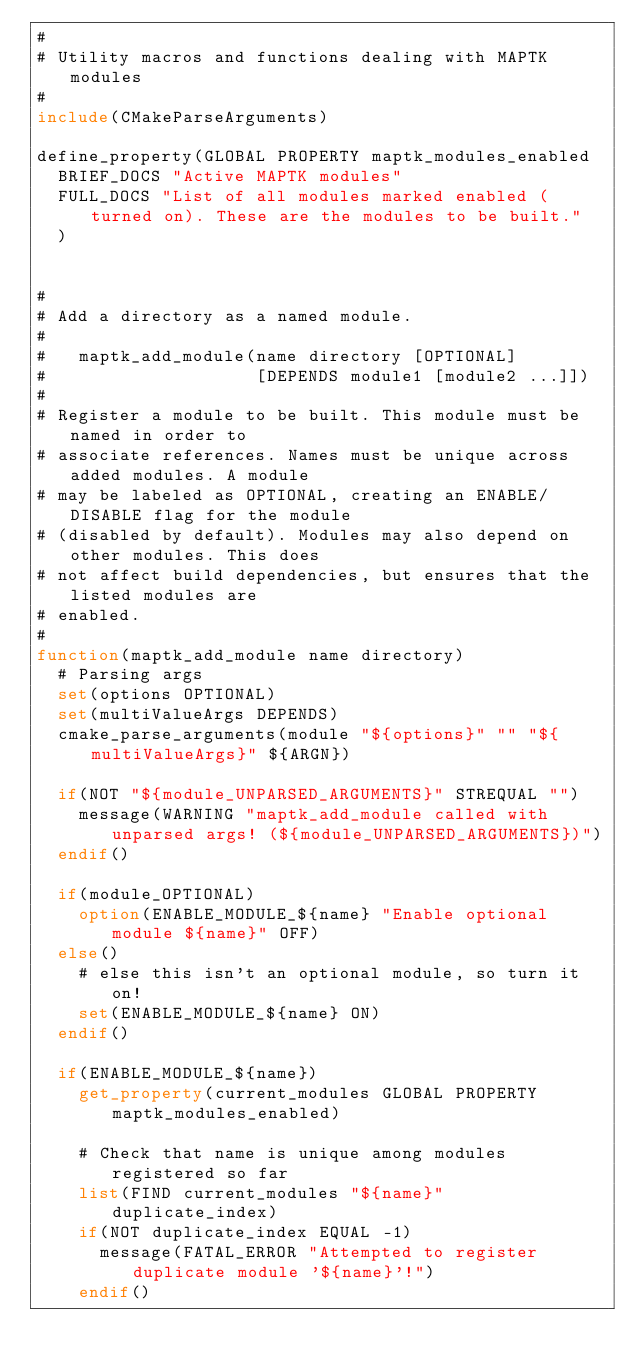Convert code to text. <code><loc_0><loc_0><loc_500><loc_500><_CMake_>#
# Utility macros and functions dealing with MAPTK modules
#
include(CMakeParseArguments)

define_property(GLOBAL PROPERTY maptk_modules_enabled
  BRIEF_DOCS "Active MAPTK modules"
  FULL_DOCS "List of all modules marked enabled (turned on). These are the modules to be built."
  )


#
# Add a directory as a named module.
#
#   maptk_add_module(name directory [OPTIONAL]
#                    [DEPENDS module1 [module2 ...]])
#
# Register a module to be built. This module must be named in order to
# associate references. Names must be unique across added modules. A module
# may be labeled as OPTIONAL, creating an ENABLE/DISABLE flag for the module
# (disabled by default). Modules may also depend on other modules. This does
# not affect build dependencies, but ensures that the listed modules are
# enabled.
#
function(maptk_add_module name directory)
  # Parsing args
  set(options OPTIONAL)
  set(multiValueArgs DEPENDS)
  cmake_parse_arguments(module "${options}" "" "${multiValueArgs}" ${ARGN})

  if(NOT "${module_UNPARSED_ARGUMENTS}" STREQUAL "")
    message(WARNING "maptk_add_module called with unparsed args! (${module_UNPARSED_ARGUMENTS})")
  endif()

  if(module_OPTIONAL)
    option(ENABLE_MODULE_${name} "Enable optional module ${name}" OFF)
  else()
    # else this isn't an optional module, so turn it on!
    set(ENABLE_MODULE_${name} ON)
  endif()

  if(ENABLE_MODULE_${name})
    get_property(current_modules GLOBAL PROPERTY maptk_modules_enabled)

    # Check that name is unique among modules registered so far
    list(FIND current_modules "${name}" duplicate_index)
    if(NOT duplicate_index EQUAL -1)
      message(FATAL_ERROR "Attempted to register duplicate module '${name}'!")
    endif()
</code> 